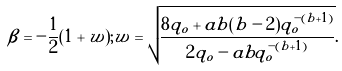<formula> <loc_0><loc_0><loc_500><loc_500>\beta = - \frac { 1 } { 2 } ( 1 + w ) ; w = \sqrt { \frac { 8 q _ { o } + a b ( b - 2 ) q _ { o } ^ { - ( b + 1 ) } } { 2 q _ { o } - a b q _ { o } ^ { - ( b + 1 ) } } } .</formula> 